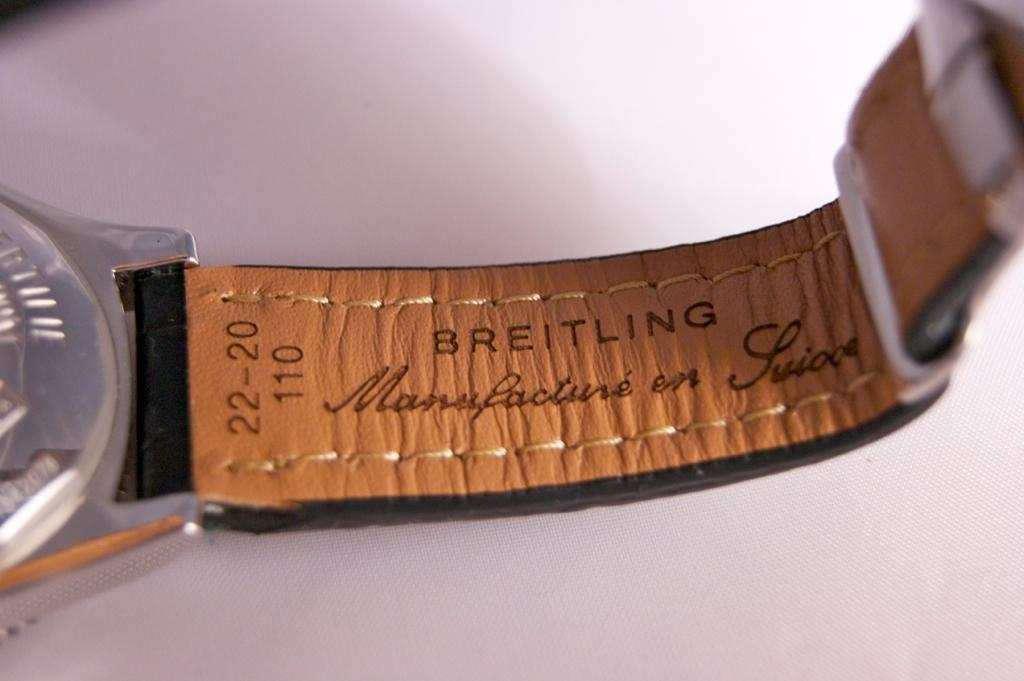<image>
Write a terse but informative summary of the picture. The underside of a Breitling leather watch wristband that was made in Suisse. 